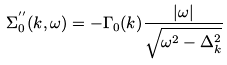<formula> <loc_0><loc_0><loc_500><loc_500>\Sigma ^ { ^ { \prime \prime } } _ { 0 } ( { k } , \omega ) = - \Gamma _ { 0 } ( { k } ) \frac { | \omega | } { \sqrt { \omega ^ { 2 } - \Delta _ { k } ^ { 2 } } }</formula> 